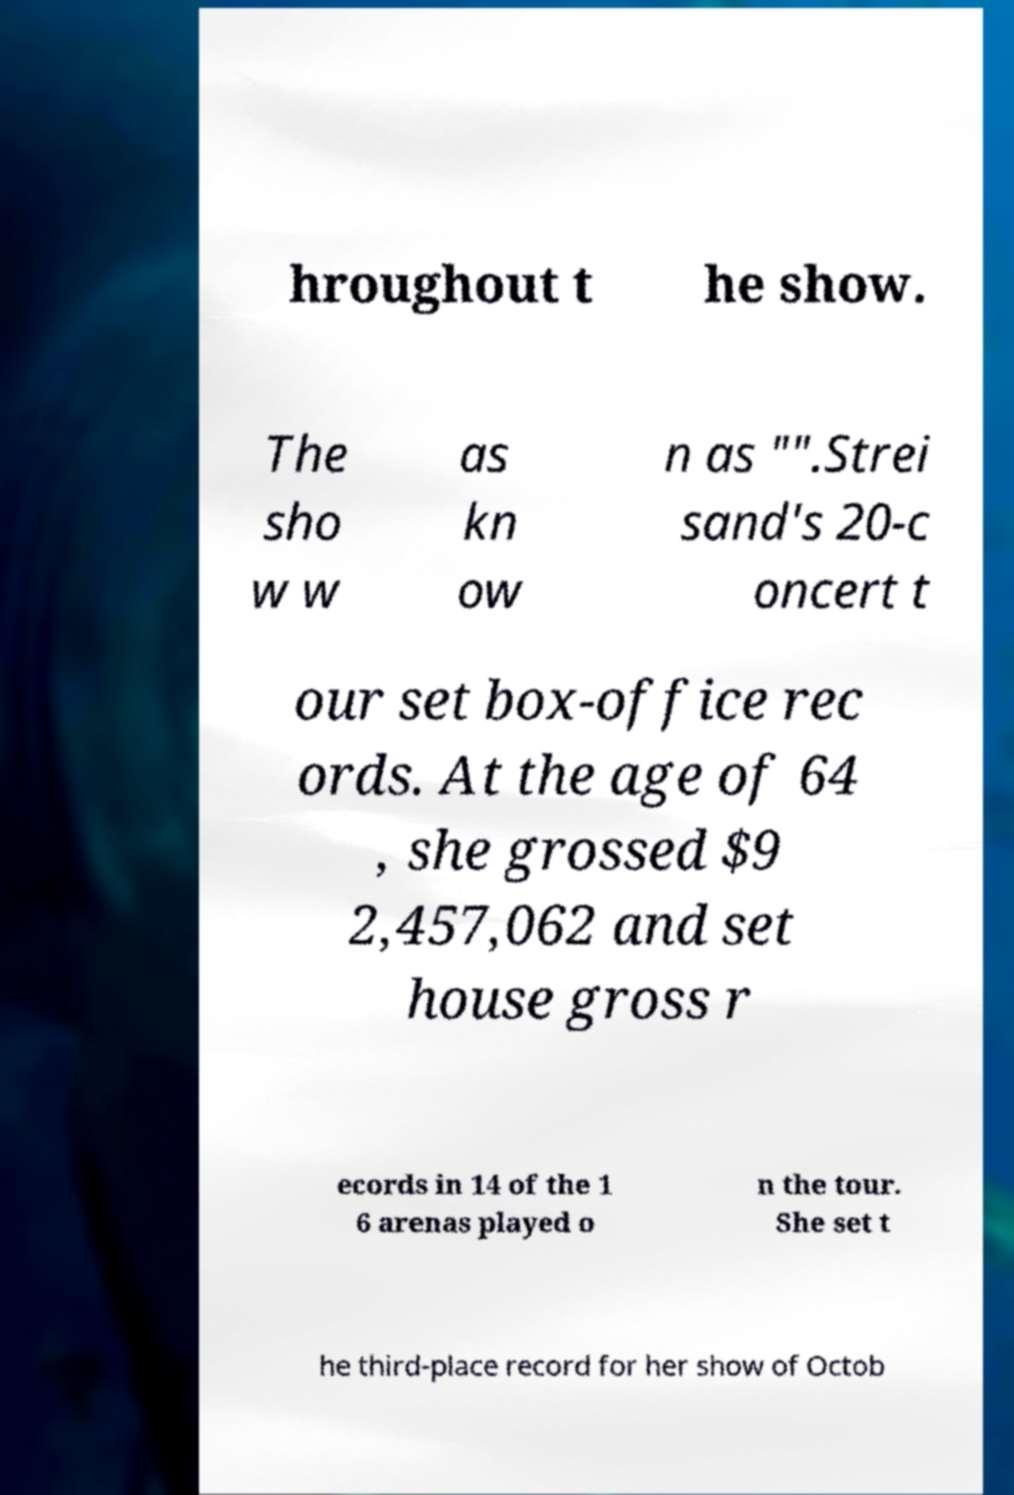There's text embedded in this image that I need extracted. Can you transcribe it verbatim? hroughout t he show. The sho w w as kn ow n as "".Strei sand's 20-c oncert t our set box-office rec ords. At the age of 64 , she grossed $9 2,457,062 and set house gross r ecords in 14 of the 1 6 arenas played o n the tour. She set t he third-place record for her show of Octob 